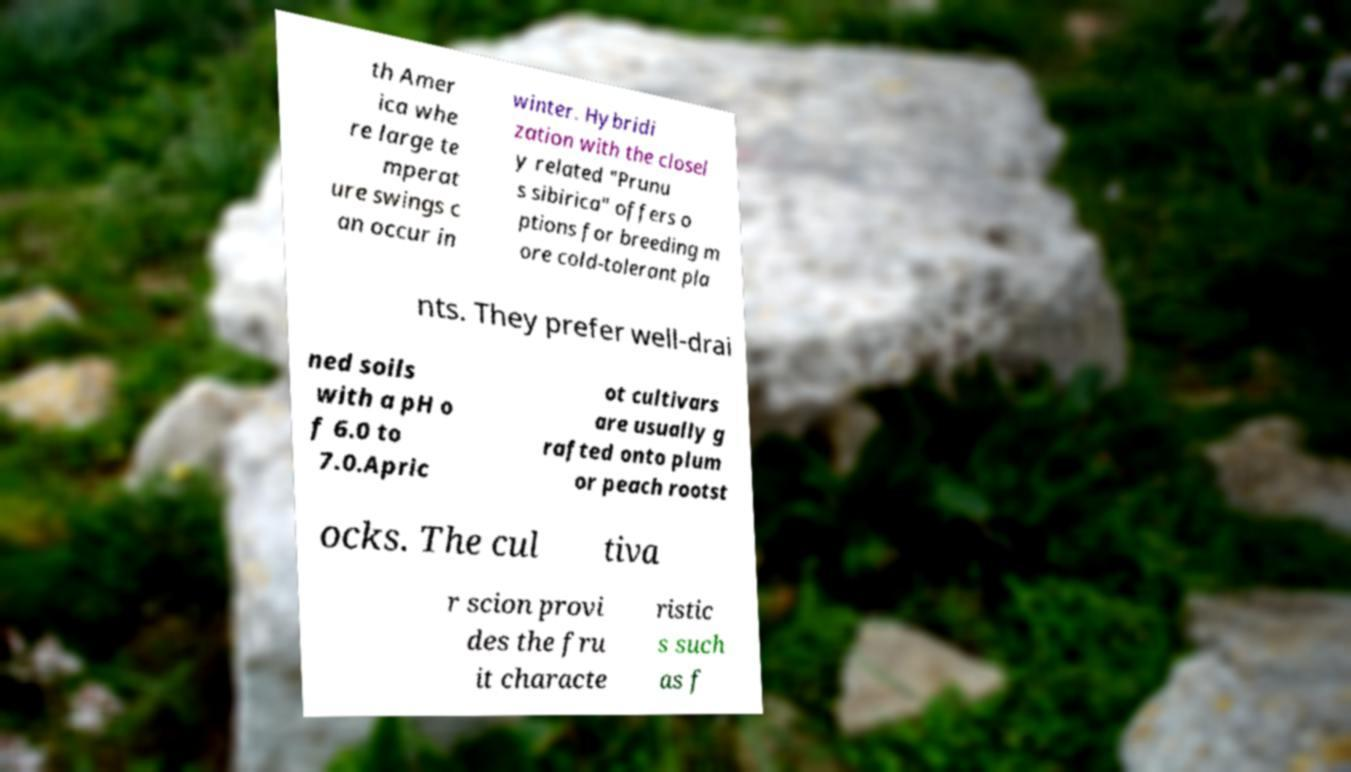Could you extract and type out the text from this image? th Amer ica whe re large te mperat ure swings c an occur in winter. Hybridi zation with the closel y related "Prunu s sibirica" offers o ptions for breeding m ore cold-tolerant pla nts. They prefer well-drai ned soils with a pH o f 6.0 to 7.0.Apric ot cultivars are usually g rafted onto plum or peach rootst ocks. The cul tiva r scion provi des the fru it characte ristic s such as f 